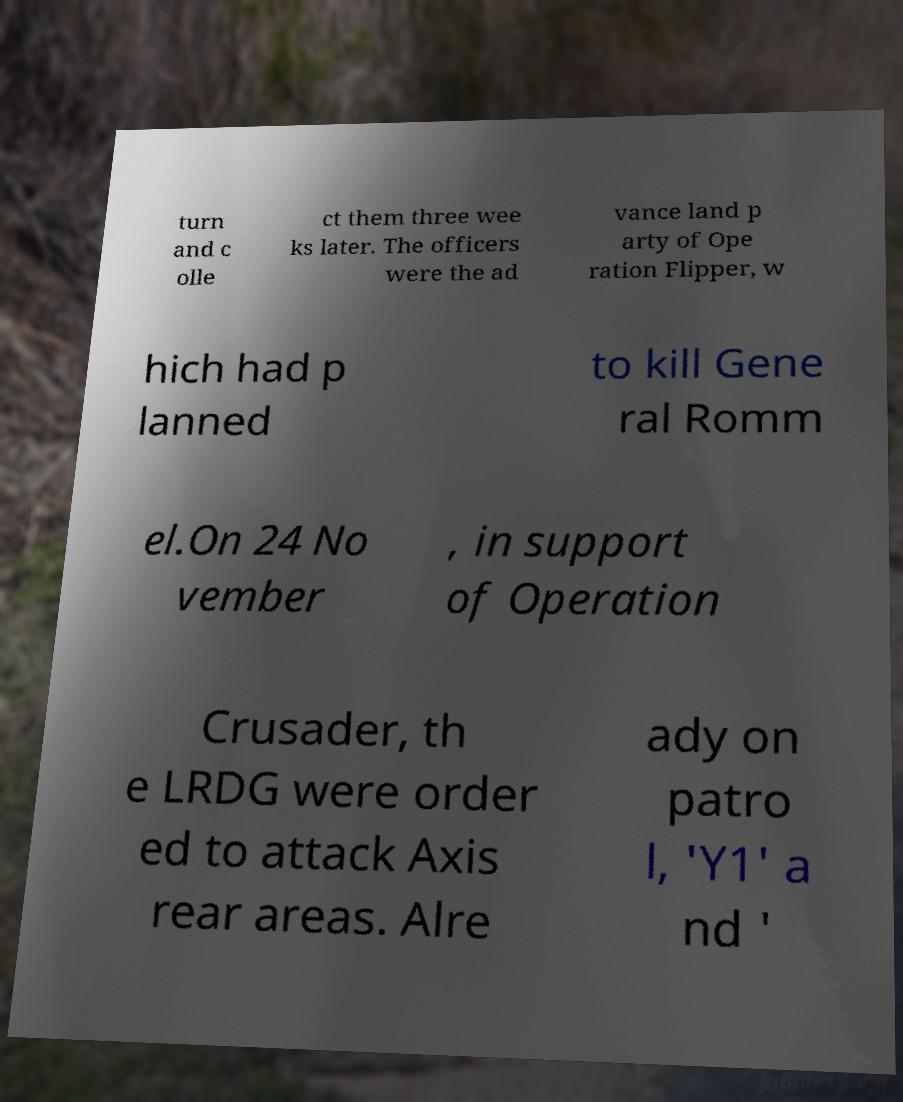For documentation purposes, I need the text within this image transcribed. Could you provide that? turn and c olle ct them three wee ks later. The officers were the ad vance land p arty of Ope ration Flipper, w hich had p lanned to kill Gene ral Romm el.On 24 No vember , in support of Operation Crusader, th e LRDG were order ed to attack Axis rear areas. Alre ady on patro l, 'Y1' a nd ' 